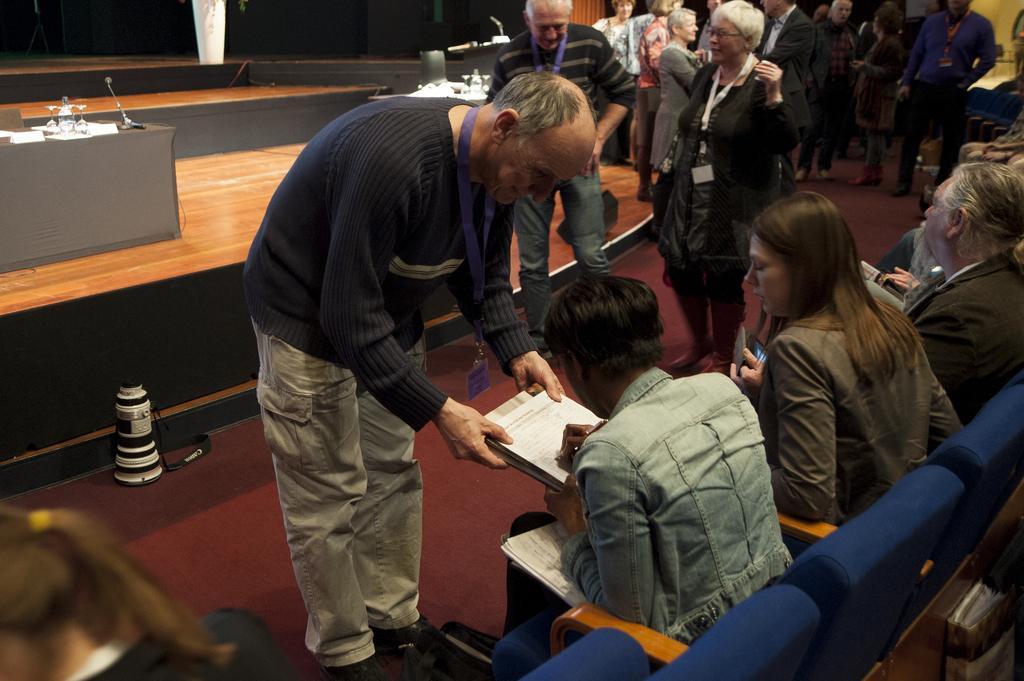How would you summarize this image in a sentence or two? In this picture we can see some people sitting on chairs, there are some people standing here, this person is writing something, in the background there is a table, we can see a microphone and some papers here. 